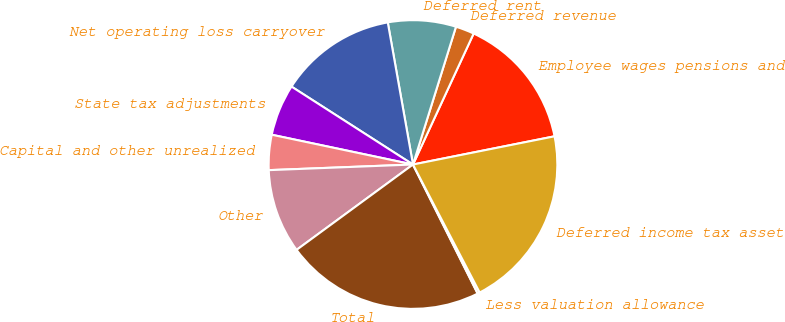Convert chart to OTSL. <chart><loc_0><loc_0><loc_500><loc_500><pie_chart><fcel>Employee wages pensions and<fcel>Deferred revenue<fcel>Deferred rent<fcel>Net operating loss carryover<fcel>State tax adjustments<fcel>Capital and other unrealized<fcel>Other<fcel>Total<fcel>Less valuation allowance<fcel>Deferred income tax asset<nl><fcel>14.97%<fcel>2.09%<fcel>7.61%<fcel>13.13%<fcel>5.77%<fcel>3.93%<fcel>9.45%<fcel>22.33%<fcel>0.25%<fcel>20.49%<nl></chart> 